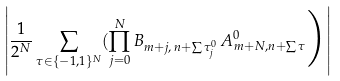<formula> <loc_0><loc_0><loc_500><loc_500>\left | \frac { 1 } { 2 ^ { N } } \sum _ { \tau \in \{ - 1 , 1 \} ^ { N } } ( \prod _ { j = 0 } ^ { N } B _ { m + j , \, n + \sum \tau ^ { 0 } _ { j } } \, A _ { m + N , n + \sum \tau } ^ { 0 } \Big ) \right |</formula> 